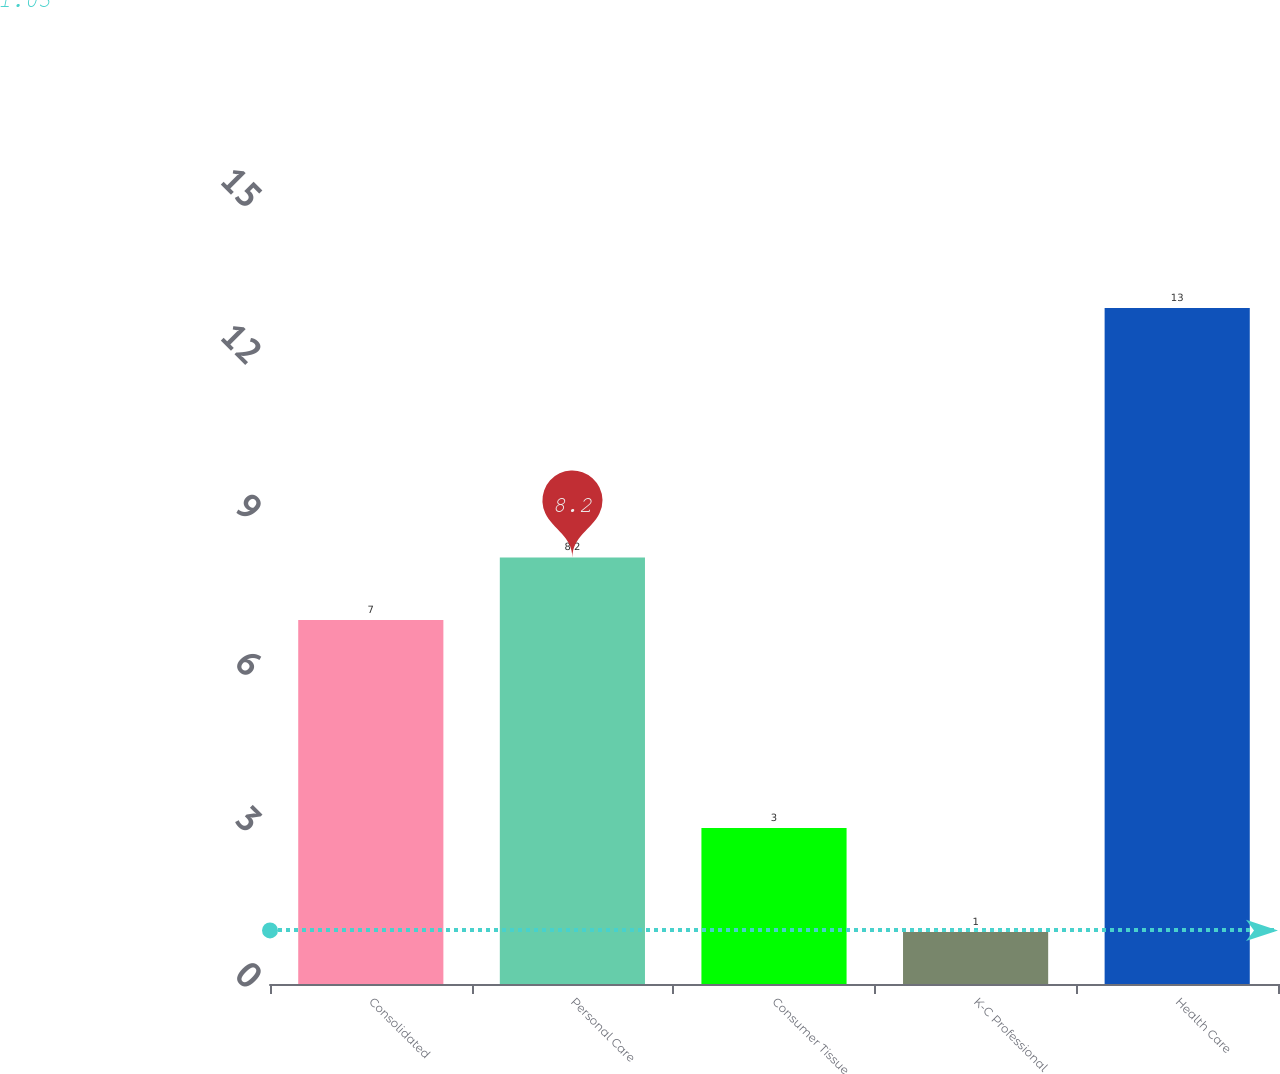Convert chart. <chart><loc_0><loc_0><loc_500><loc_500><bar_chart><fcel>Consolidated<fcel>Personal Care<fcel>Consumer Tissue<fcel>K-C Professional<fcel>Health Care<nl><fcel>7<fcel>8.2<fcel>3<fcel>1<fcel>13<nl></chart> 